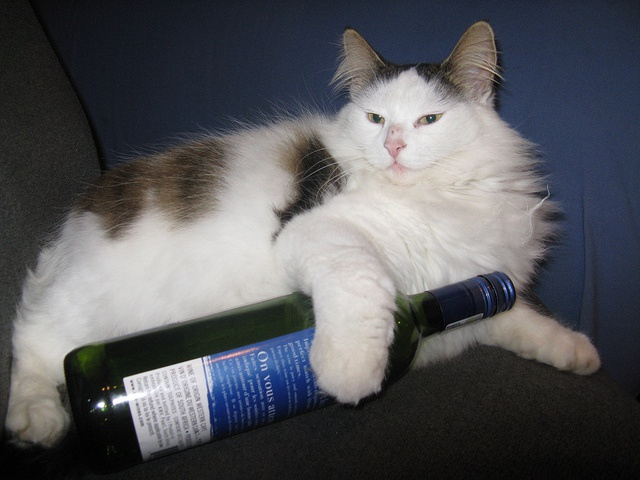Describe the objects in this image and their specific colors. I can see cat in black, lightgray, darkgray, and gray tones and bottle in black, gray, darkgray, and lightgray tones in this image. 